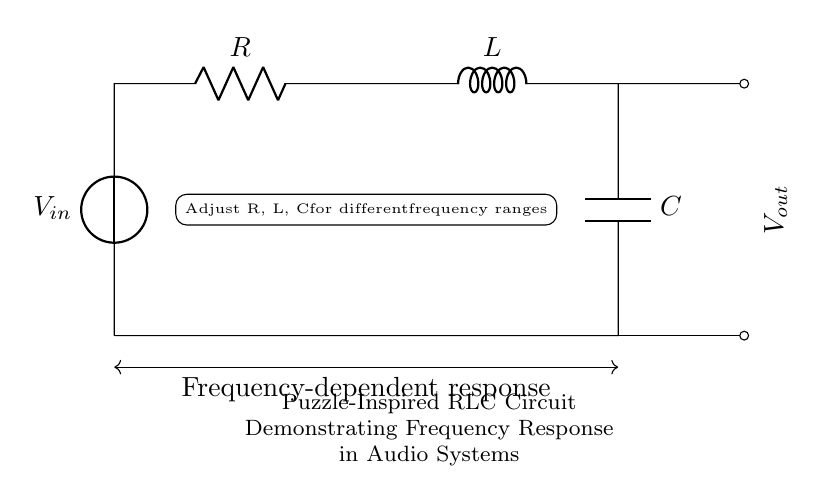What are the components in this circuit? The circuit contains a voltage source, resistor, inductor, and capacitor. These components are essential for its function, demonstrating how they interact to affect the circuit's frequency response.
Answer: voltage source, resistor, inductor, capacitor What is the role of the resistor in this circuit? The resistor limits the current flow and dissipates energy as heat, impacting the overall impedance of the circuit at different frequencies. This affects how the circuit responds to various input frequencies.
Answer: limits current What does the label Vout indicate in the circuit? Vout represents the output voltage measurement taken across the capacitor and inductor. It provides insight into how the RLC circuit reacts to the input signal, which is critical in analyzing frequency response.
Answer: output voltage How can the frequency response of the circuit be altered? The frequency response can be adjusted by changing the values of R, L, and C. Each component influences the circuit's resonance and the frequencies at which it responds maximally or minimally.
Answer: adjust R, L, C What type of filtering does this RLC circuit primarily provide? This RLC circuit can act as a band-pass filter, allowing certain frequency ranges to pass while attenuating others. The combination of the resistor, inductor, and capacitor helps to define the passband.
Answer: band-pass filter What is the significance of the phrase “Frequency-dependent response”? The phrase highlights that the behavior of the circuit changes with frequency, demonstrating that different input frequencies will elicit different output responses. This is a key concept in understanding audio applications.
Answer: behavior changes with frequency What two outputs are indicated near the capacitor and inductor? The two outputs indicated are the points where the output voltage is measured from the capacitor and the inductor, respectively. This gives a clear reference for analyzing how the circuit behaves at these components.
Answer: Vout from capacitor and inductor 